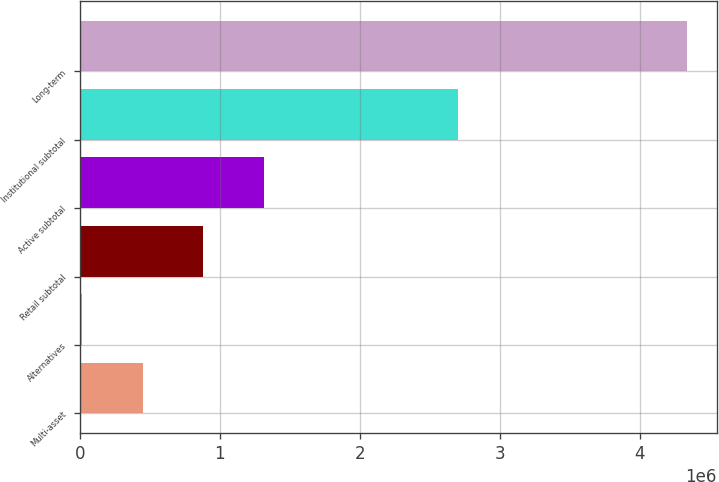Convert chart. <chart><loc_0><loc_0><loc_500><loc_500><bar_chart><fcel>Multi-asset<fcel>Alternatives<fcel>Retail subtotal<fcel>Active subtotal<fcel>Institutional subtotal<fcel>Long-term<nl><fcel>451000<fcel>19410<fcel>882591<fcel>1.31418e+06<fcel>2.70163e+06<fcel>4.33532e+06<nl></chart> 